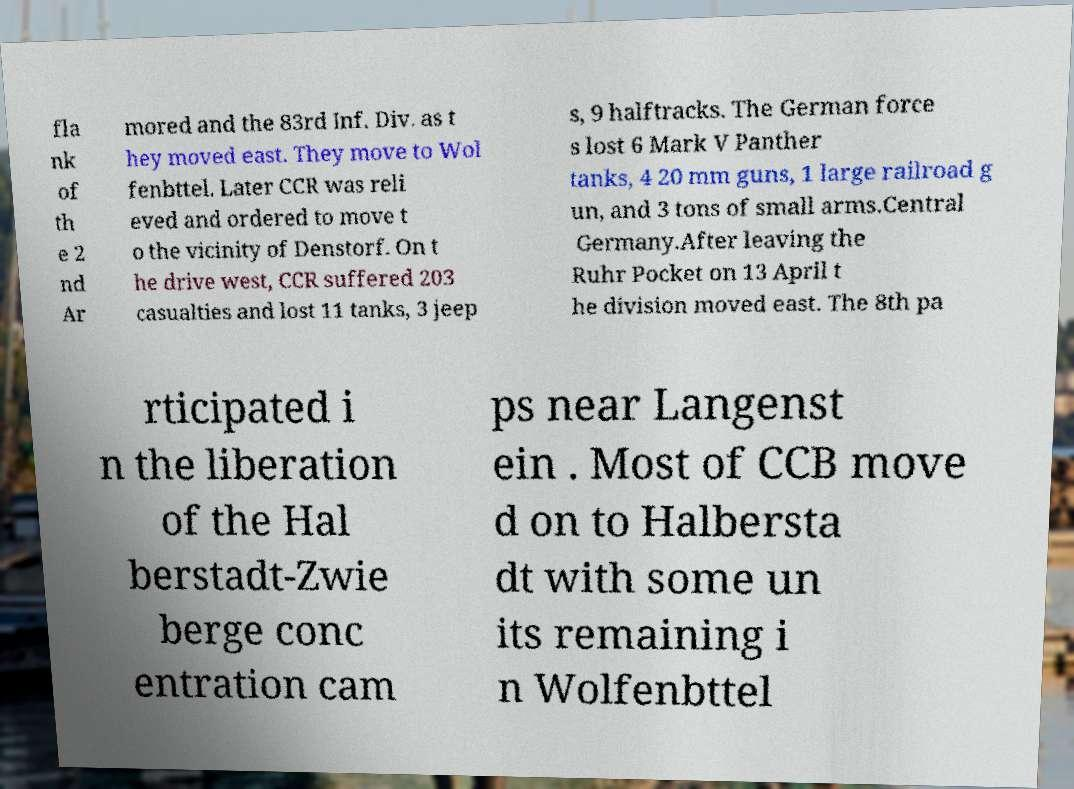Could you assist in decoding the text presented in this image and type it out clearly? fla nk of th e 2 nd Ar mored and the 83rd Inf. Div. as t hey moved east. They move to Wol fenbttel. Later CCR was reli eved and ordered to move t o the vicinity of Denstorf. On t he drive west, CCR suffered 203 casualties and lost 11 tanks, 3 jeep s, 9 halftracks. The German force s lost 6 Mark V Panther tanks, 4 20 mm guns, 1 large railroad g un, and 3 tons of small arms.Central Germany.After leaving the Ruhr Pocket on 13 April t he division moved east. The 8th pa rticipated i n the liberation of the Hal berstadt-Zwie berge conc entration cam ps near Langenst ein . Most of CCB move d on to Halbersta dt with some un its remaining i n Wolfenbttel 